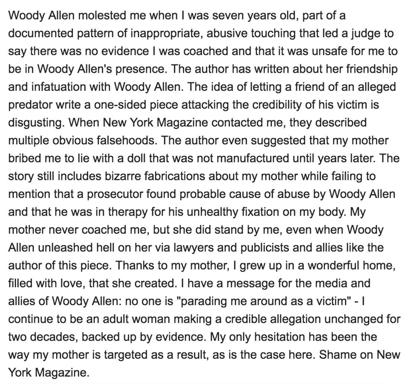What message does the author want to convey to the media and allies of Woody Allen? The author emphasizes a strong, personal plea to the media and the supporters of Woody Allen, urging them not to trivialize her standing or victimize her in the public eye. She asserts that her allegations have remained consistent and are supported by substantial evidence, even as she criticizes the unfair targeting and vilification of her mother due to these allegations. 